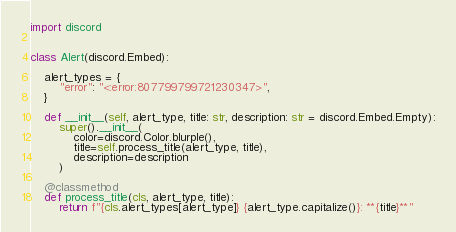<code> <loc_0><loc_0><loc_500><loc_500><_Python_>import discord


class Alert(discord.Embed):

    alert_types = {
        "error": "<:error:807799799721230347>",
    }

    def __init__(self, alert_type, title: str, description: str = discord.Embed.Empty):
        super().__init__(
            color=discord.Color.blurple(),
            title=self.process_title(alert_type, title),
            description=description
        )

    @classmethod
    def process_title(cls, alert_type, title):
        return f"{cls.alert_types[alert_type]} {alert_type.capitalize()}: **{title}**"
</code> 